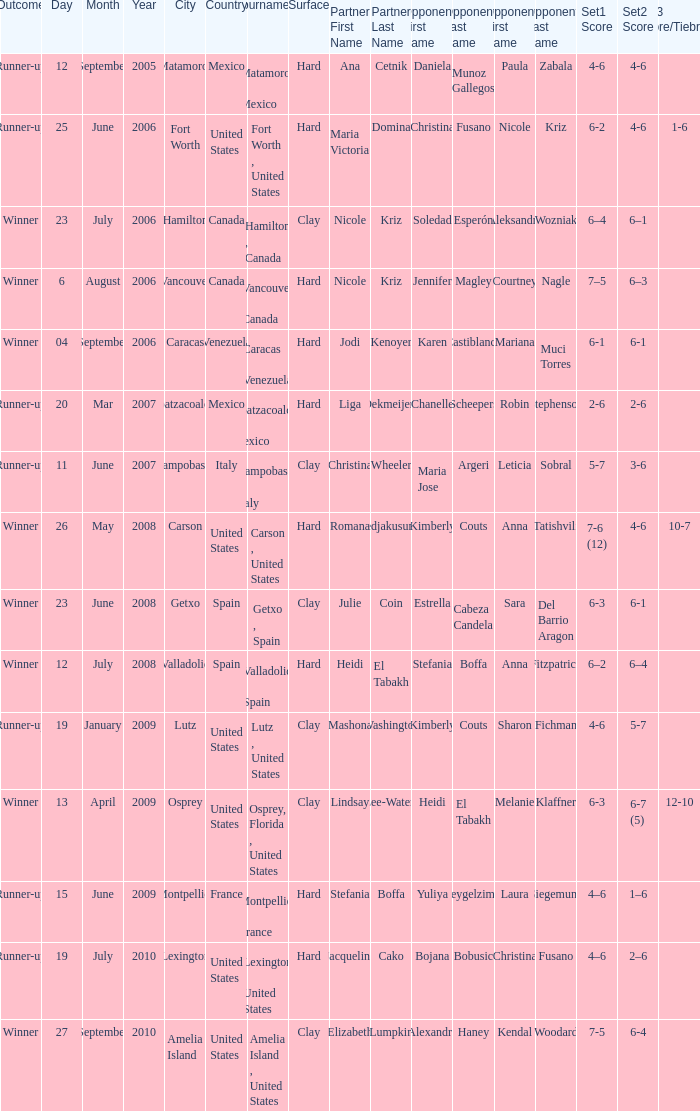What was the date for the match where Tweedie-Yates' partner was jodi kenoyer? 04 September 2006. 